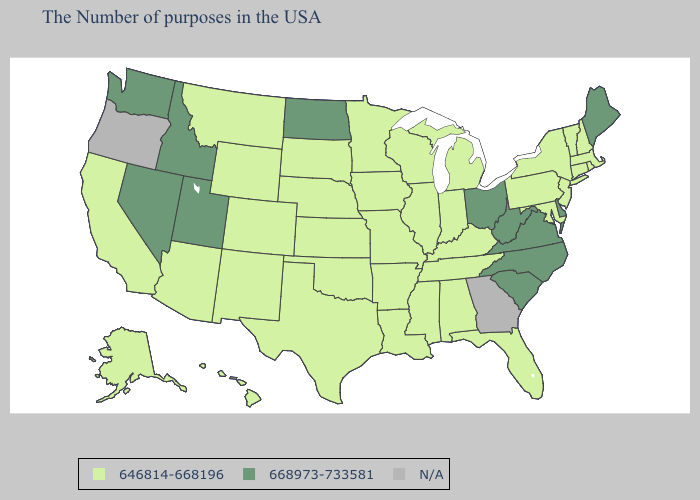Among the states that border West Virginia , does Kentucky have the highest value?
Short answer required. No. What is the value of Maine?
Concise answer only. 668973-733581. Does Arkansas have the highest value in the USA?
Keep it brief. No. What is the value of New Hampshire?
Concise answer only. 646814-668196. Name the states that have a value in the range N/A?
Short answer required. Georgia, Oregon. Does Utah have the highest value in the West?
Keep it brief. Yes. What is the highest value in states that border South Dakota?
Answer briefly. 668973-733581. Among the states that border Missouri , which have the lowest value?
Short answer required. Kentucky, Tennessee, Illinois, Arkansas, Iowa, Kansas, Nebraska, Oklahoma. Which states hav the highest value in the MidWest?
Give a very brief answer. Ohio, North Dakota. What is the value of New York?
Quick response, please. 646814-668196. What is the lowest value in the USA?
Be succinct. 646814-668196. 